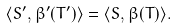Convert formula to latex. <formula><loc_0><loc_0><loc_500><loc_500>\langle S ^ { \prime } , \beta ^ { \prime } ( T ^ { \prime } ) \rangle = \langle S , \beta ( T ) \rangle .</formula> 